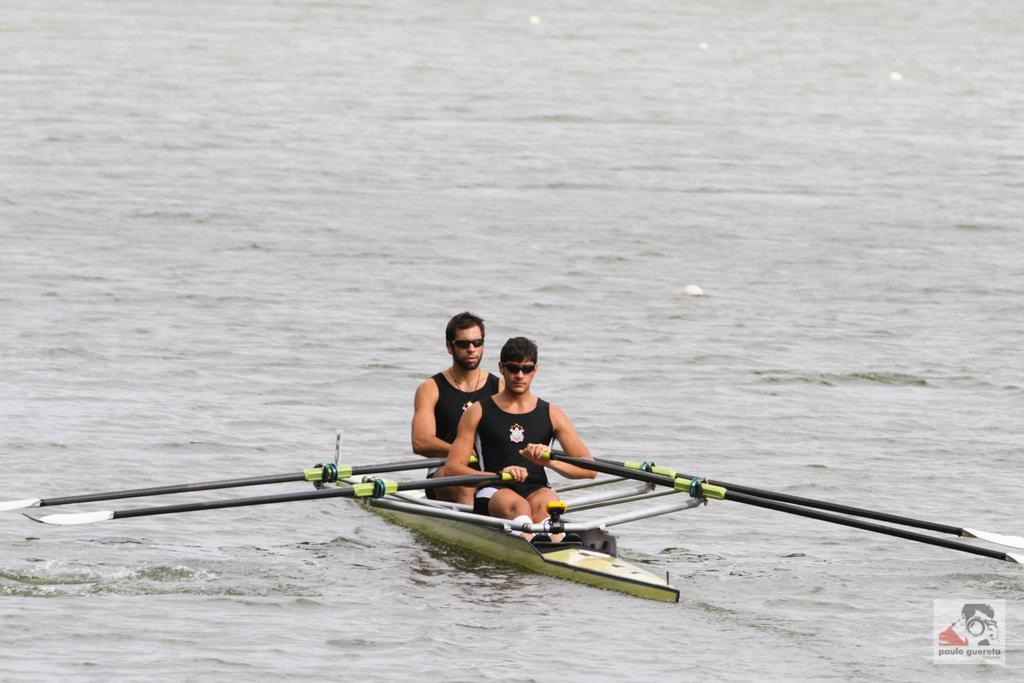Please provide a concise description of this image. In this picture there is a boat in the center of the image, on the water and there are two men on the boat, by holding ears in their hands and there is water around the area of the image. 